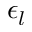<formula> <loc_0><loc_0><loc_500><loc_500>\epsilon _ { l }</formula> 